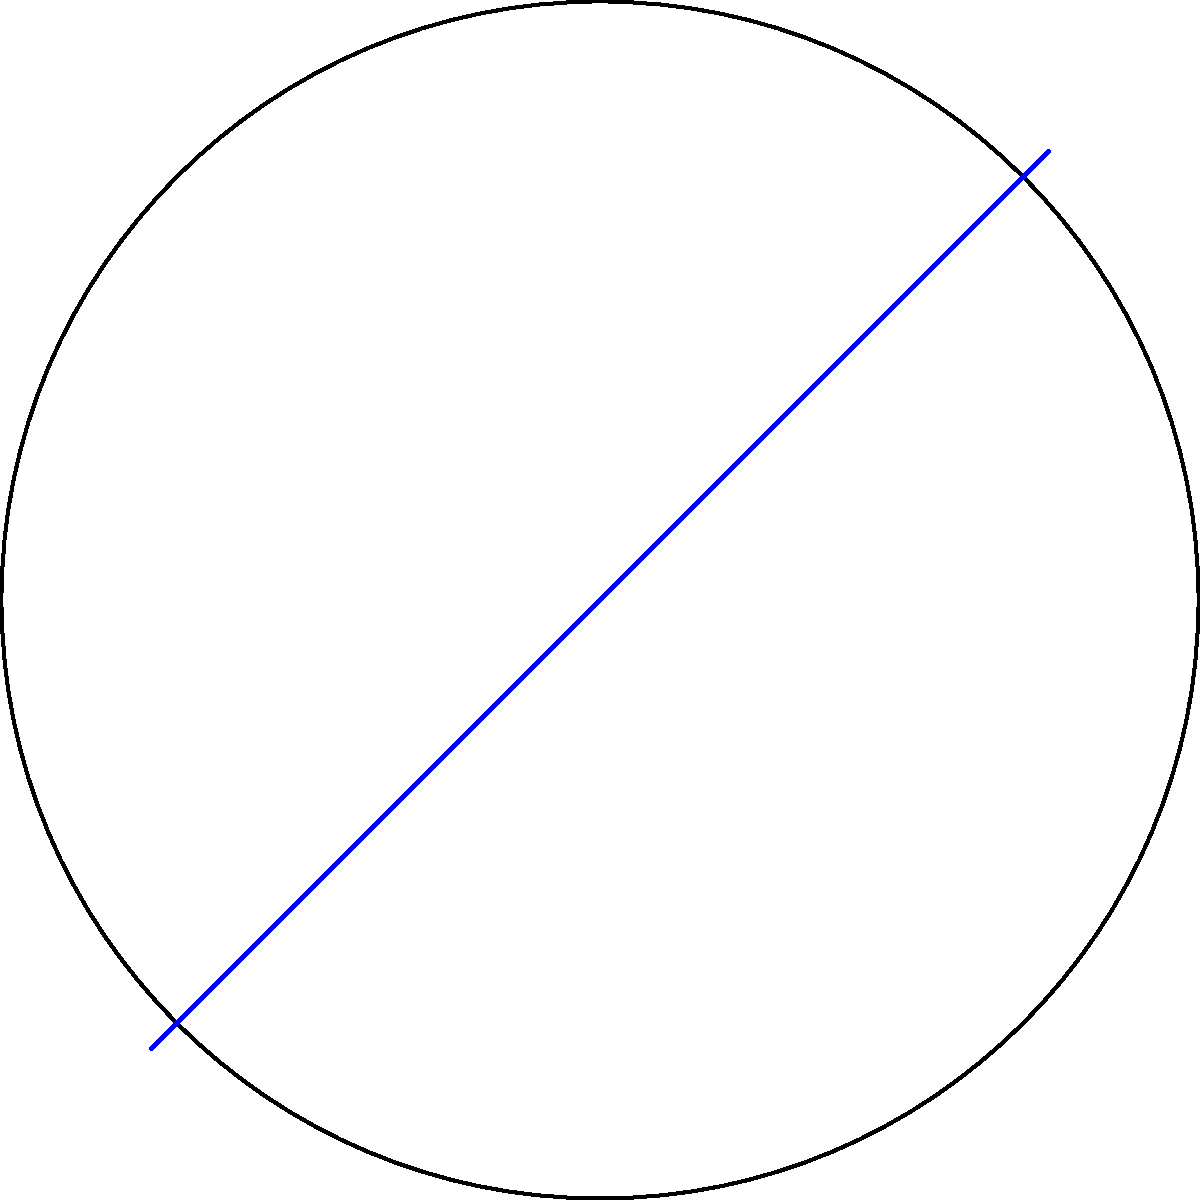On the Oregon Ducks' new non-Euclidean basketball court, which is shaped like a disk in the Poincaré model of hyperbolic geometry, a player needs to run from point A to point B. Which path represents the shortest distance between these two points: the straight line (blue) or the curved arc (red)? To determine the shortest path in the Poincaré disk model of hyperbolic geometry, we need to consider the following steps:

1. Recognize that in hyperbolic geometry, straight lines are represented by arcs perpendicular to the boundary circle of the Poincaré disk.

2. Observe that the red arc in the diagram is part of a circle that intersects the boundary of the disk at right angles.

3. Understand that in hyperbolic geometry, the shortest path between two points (known as a geodesic) is represented by these perpendicular arcs in the Poincaré disk model.

4. Note that the blue line, while appearing straight in Euclidean geometry, does not represent the shortest path in hyperbolic geometry.

5. Conclude that the red arc, being a geodesic in the Poincaré disk model, represents the shortest path between points A and B in this non-Euclidean court.

This concept is crucial for understanding how players would navigate most efficiently on such a hypothetical non-Euclidean court, demonstrating that the intuitive straight line is not always the optimal path in non-Euclidean geometries.
Answer: The curved arc (red path) 